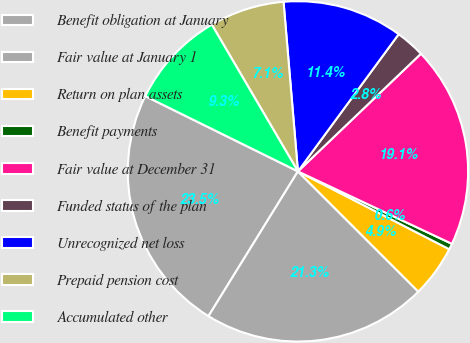Convert chart. <chart><loc_0><loc_0><loc_500><loc_500><pie_chart><fcel>Benefit obligation at January<fcel>Fair value at January 1<fcel>Return on plan assets<fcel>Benefit payments<fcel>Fair value at December 31<fcel>Funded status of the plan<fcel>Unrecognized net loss<fcel>Prepaid pension cost<fcel>Accumulated other<nl><fcel>23.48%<fcel>21.32%<fcel>4.93%<fcel>0.56%<fcel>19.15%<fcel>2.77%<fcel>11.43%<fcel>7.1%<fcel>9.26%<nl></chart> 